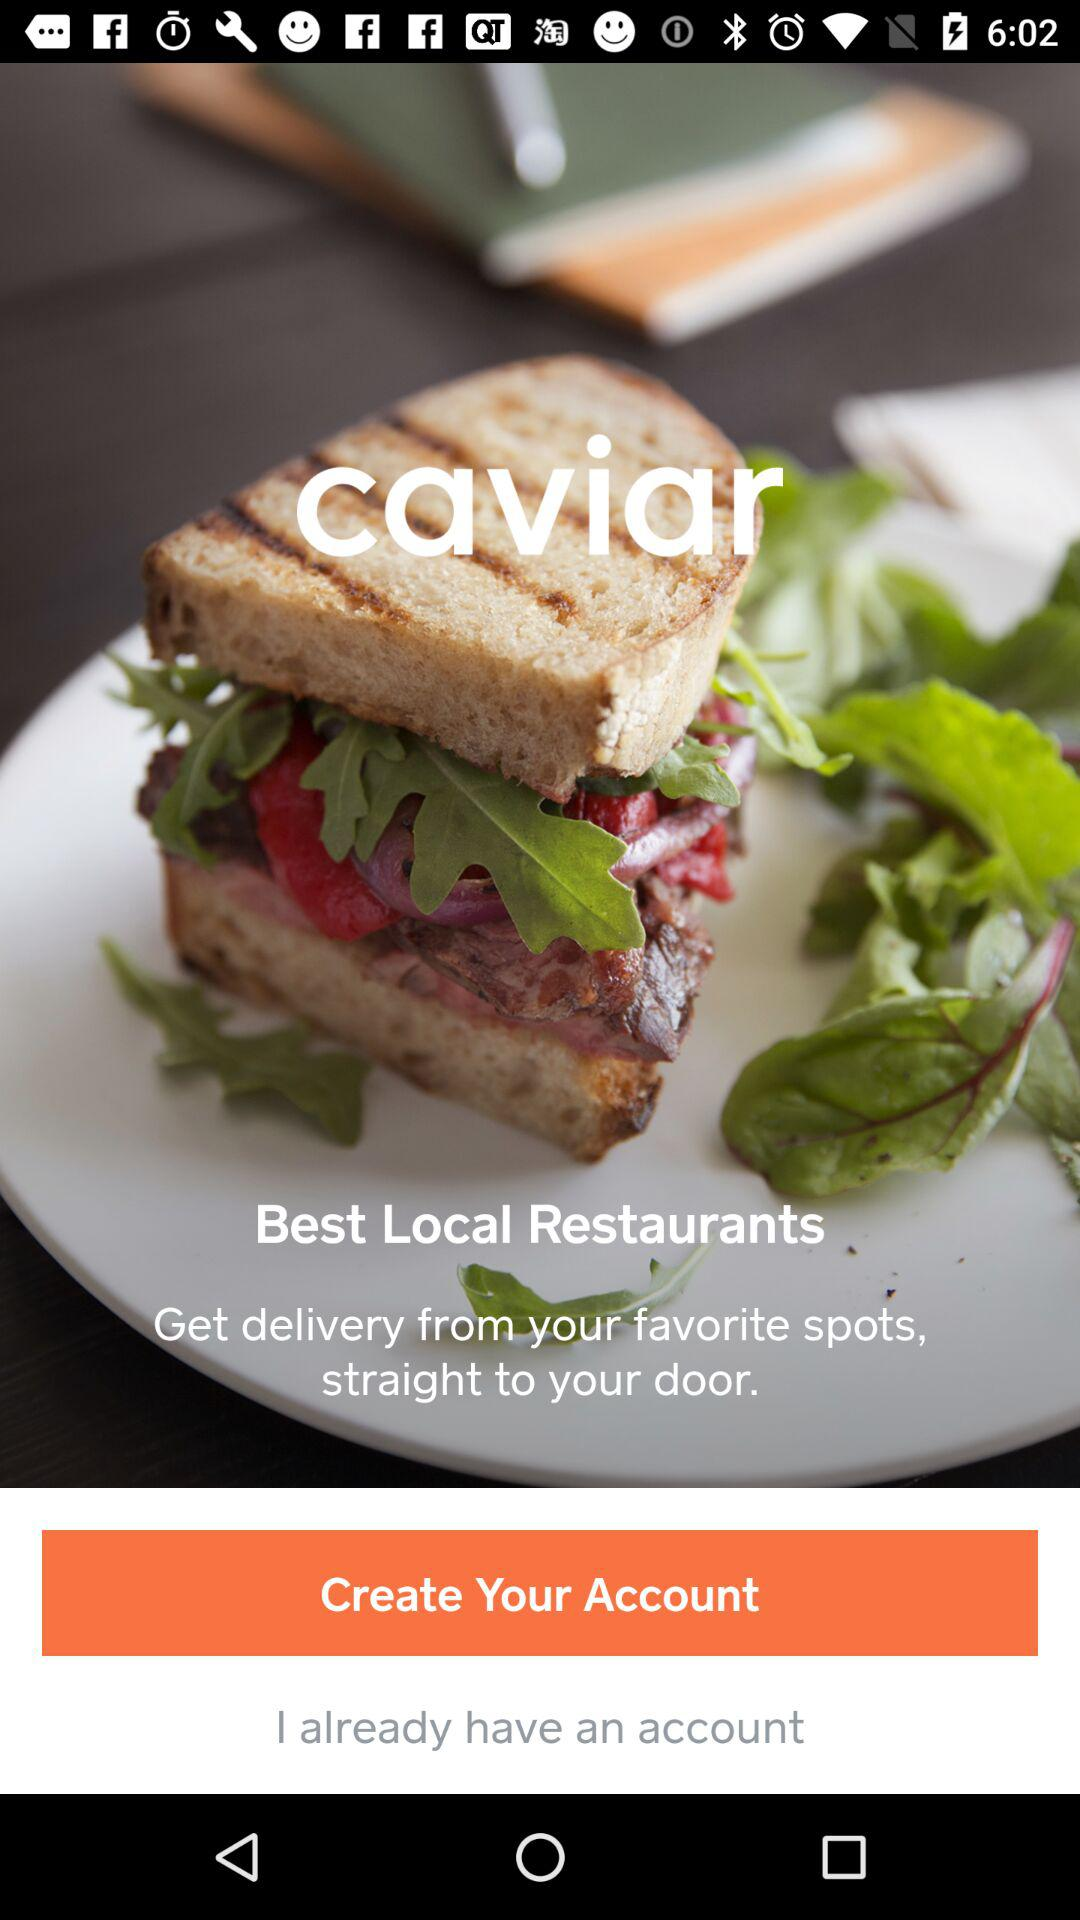What is the application name? The application name is "caviar". 